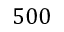Convert formula to latex. <formula><loc_0><loc_0><loc_500><loc_500>5 0 0</formula> 